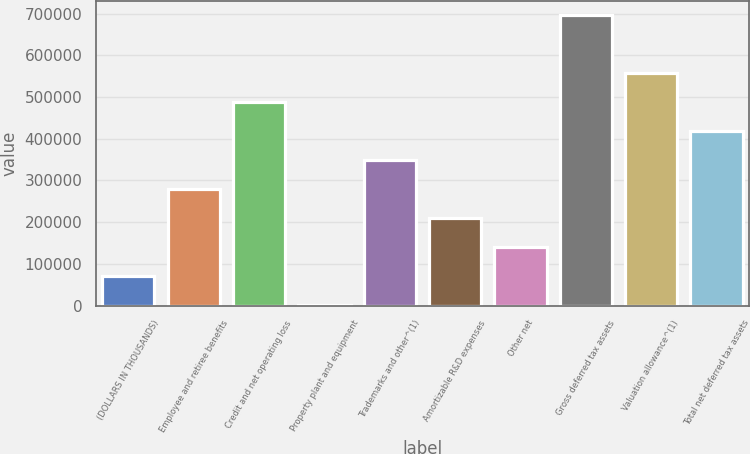<chart> <loc_0><loc_0><loc_500><loc_500><bar_chart><fcel>(DOLLARS IN THOUSANDS)<fcel>Employee and retiree benefits<fcel>Credit and net operating loss<fcel>Property plant and equipment<fcel>Trademarks and other^(1)<fcel>Amortizable R&D expenses<fcel>Other net<fcel>Gross deferred tax assets<fcel>Valuation allowance^(1)<fcel>Total net deferred tax assets<nl><fcel>70232<fcel>278831<fcel>487430<fcel>699<fcel>348364<fcel>209298<fcel>139765<fcel>696029<fcel>556963<fcel>417897<nl></chart> 